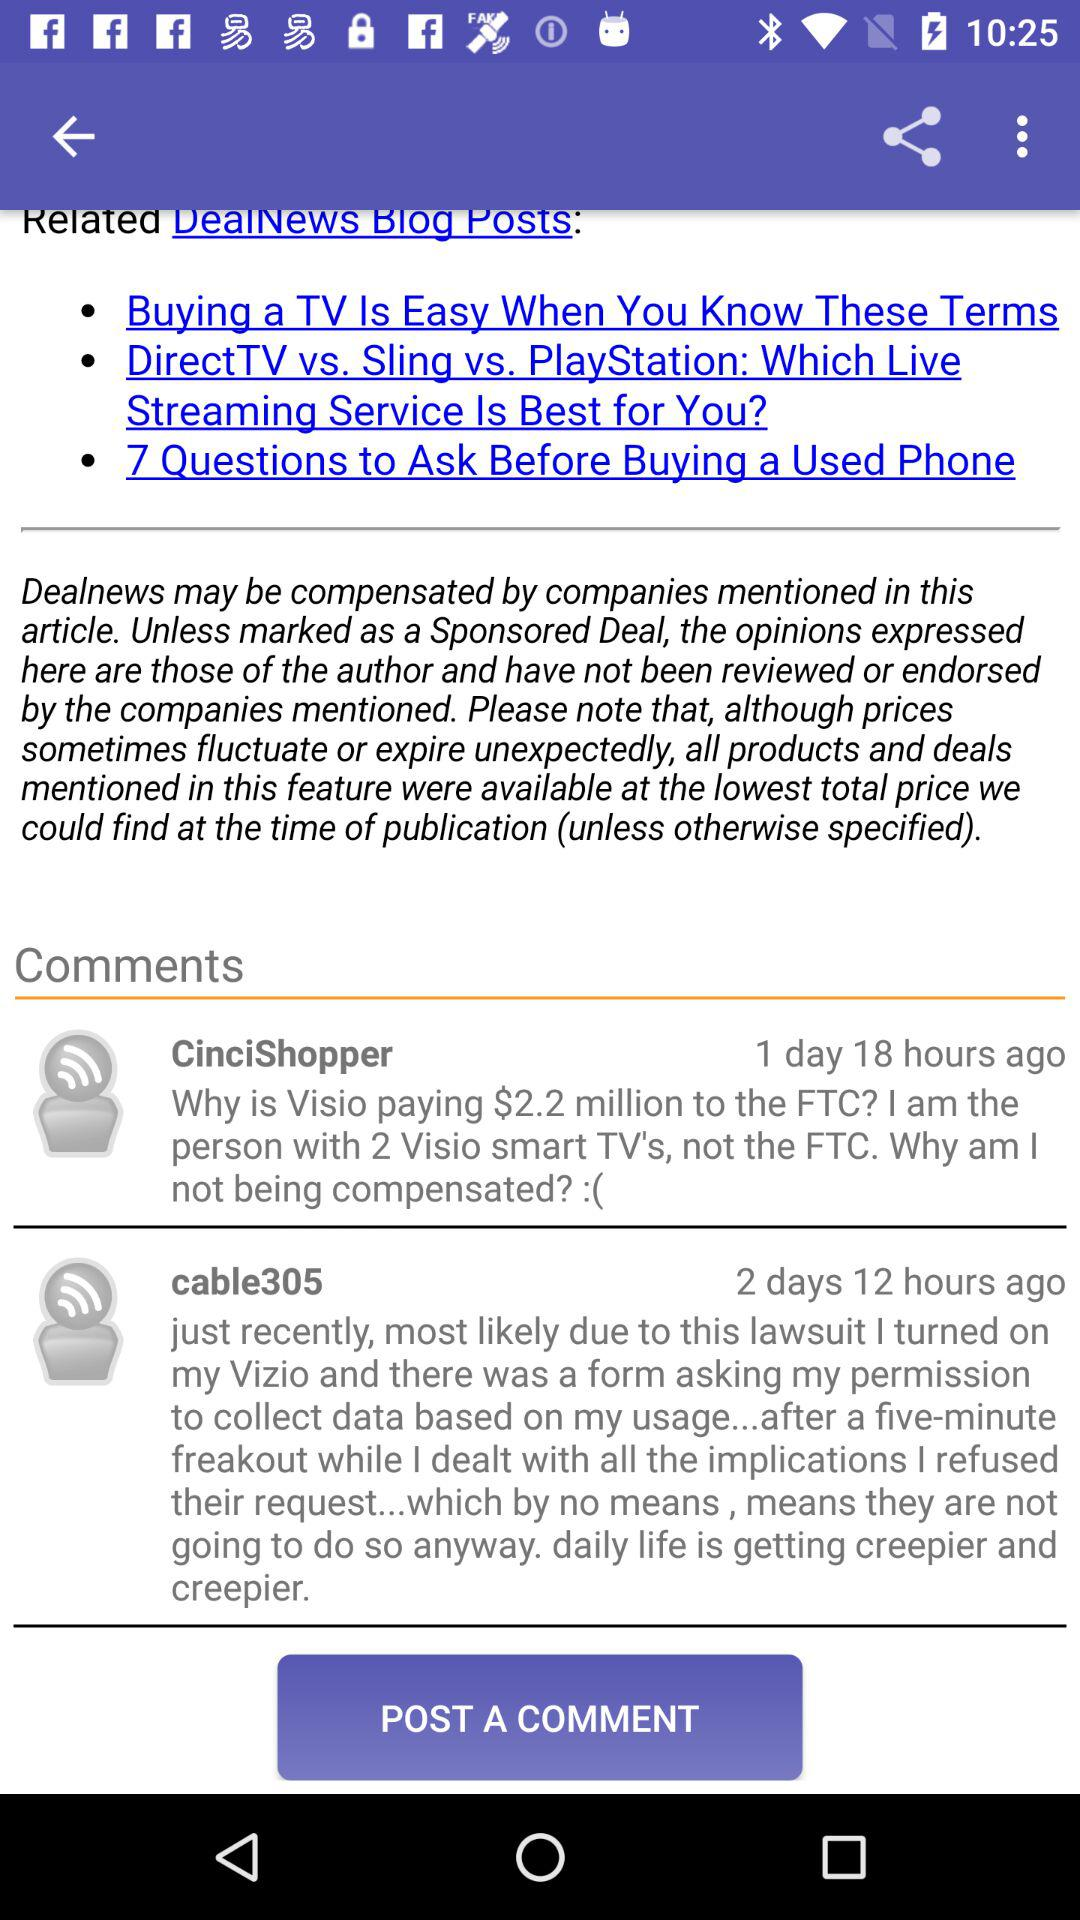How many comments are there on this article?
Answer the question using a single word or phrase. 2 